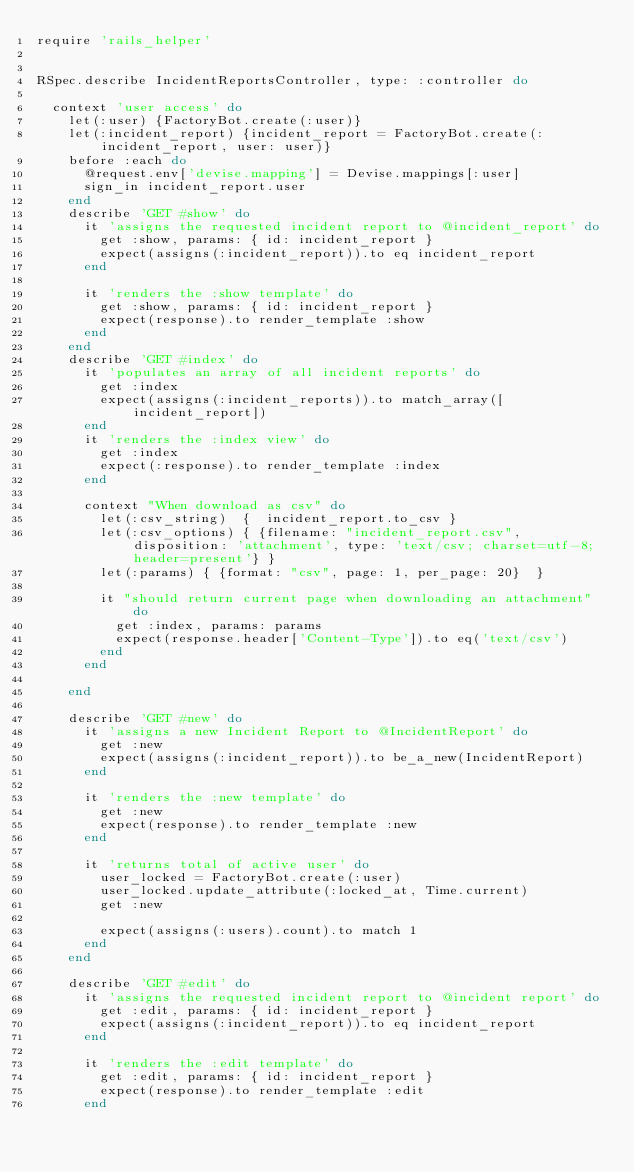<code> <loc_0><loc_0><loc_500><loc_500><_Ruby_>require 'rails_helper'


RSpec.describe IncidentReportsController, type: :controller do
  
  context 'user access' do
    let(:user) {FactoryBot.create(:user)}
    let(:incident_report) {incident_report = FactoryBot.create(:incident_report, user: user)}
    before :each do
      @request.env['devise.mapping'] = Devise.mappings[:user]
      sign_in incident_report.user
    end
    describe 'GET #show' do
      it 'assigns the requested incident report to @incident_report' do
        get :show, params: { id: incident_report }
        expect(assigns(:incident_report)).to eq incident_report
      end

      it 'renders the :show template' do
        get :show, params: { id: incident_report }
        expect(response).to render_template :show
      end
    end
    describe 'GET #index' do
      it 'populates an array of all incident reports' do
        get :index
        expect(assigns(:incident_reports)).to match_array([incident_report])
      end
      it 'renders the :index view' do
        get :index
        expect(:response).to render_template :index
      end

      context "When download as csv" do
        let(:csv_string)  {  incident_report.to_csv }
        let(:csv_options) { {filename: "incident_report.csv", disposition: 'attachment', type: 'text/csv; charset=utf-8; header=present'} }
        let(:params) { {format: "csv", page: 1, per_page: 20}  }

        it "should return current page when downloading an attachment" do
          get :index, params: params
          expect(response.header['Content-Type']).to eq('text/csv')
        end
      end

    end

    describe 'GET #new' do
      it 'assigns a new Incident Report to @IncidentReport' do
        get :new
        expect(assigns(:incident_report)).to be_a_new(IncidentReport)
      end

      it 'renders the :new template' do
        get :new
        expect(response).to render_template :new
      end

      it 'returns total of active user' do
        user_locked = FactoryBot.create(:user)
        user_locked.update_attribute(:locked_at, Time.current)
        get :new

        expect(assigns(:users).count).to match 1
      end
    end

    describe 'GET #edit' do
      it 'assigns the requested incident report to @incident report' do
        get :edit, params: { id: incident_report }
        expect(assigns(:incident_report)).to eq incident_report
      end

      it 'renders the :edit template' do
        get :edit, params: { id: incident_report }
        expect(response).to render_template :edit
      end
</code> 